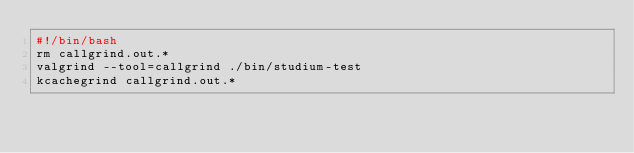Convert code to text. <code><loc_0><loc_0><loc_500><loc_500><_Bash_>#!/bin/bash
rm callgrind.out.*
valgrind --tool=callgrind ./bin/studium-test
kcachegrind callgrind.out.*

</code> 